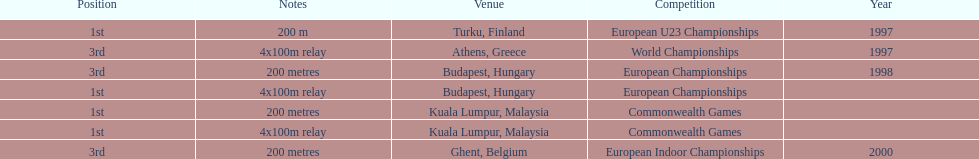Write the full table. {'header': ['Position', 'Notes', 'Venue', 'Competition', 'Year'], 'rows': [['1st', '200 m', 'Turku, Finland', 'European U23 Championships', '1997'], ['3rd', '4x100m relay', 'Athens, Greece', 'World Championships', '1997'], ['3rd', '200 metres', 'Budapest, Hungary', 'European Championships', '1998'], ['1st', '4x100m relay', 'Budapest, Hungary', 'European Championships', ''], ['1st', '200 metres', 'Kuala Lumpur, Malaysia', 'Commonwealth Games', ''], ['1st', '4x100m relay', 'Kuala Lumpur, Malaysia', 'Commonwealth Games', ''], ['3rd', '200 metres', 'Ghent, Belgium', 'European Indoor Championships', '2000']]} List the competitions that have the same relay as world championships from athens, greece. European Championships, Commonwealth Games. 